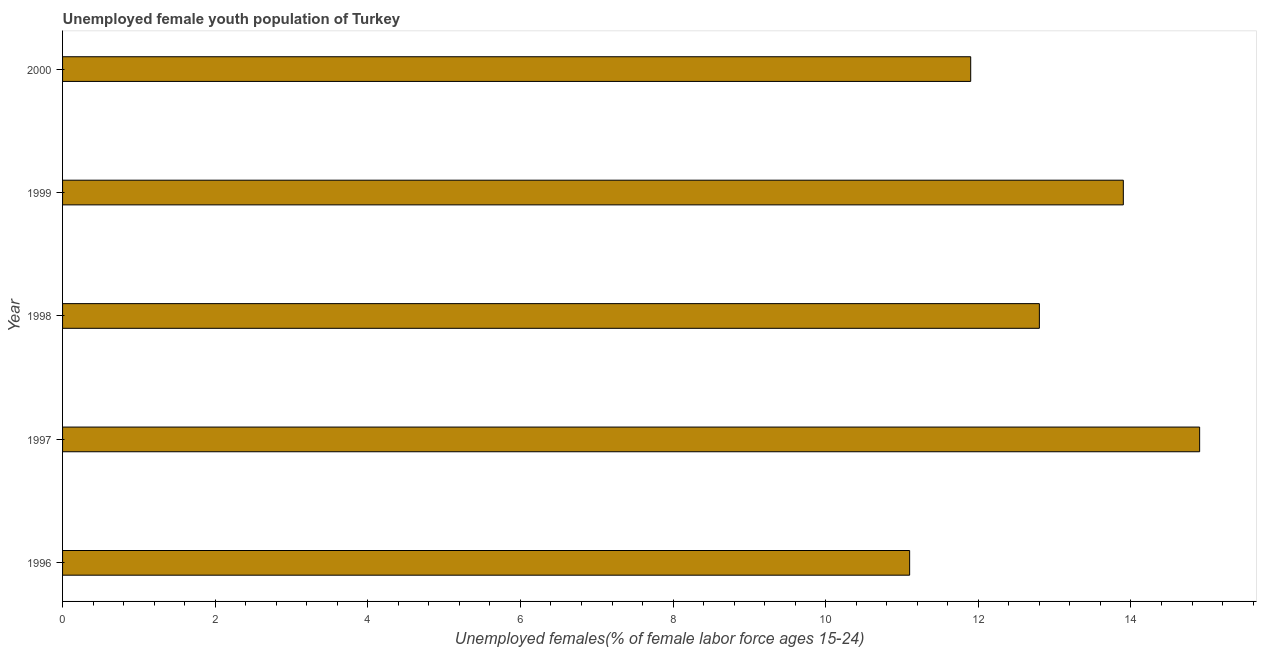What is the title of the graph?
Provide a succinct answer. Unemployed female youth population of Turkey. What is the label or title of the X-axis?
Keep it short and to the point. Unemployed females(% of female labor force ages 15-24). What is the label or title of the Y-axis?
Offer a terse response. Year. What is the unemployed female youth in 1999?
Provide a short and direct response. 13.9. Across all years, what is the maximum unemployed female youth?
Give a very brief answer. 14.9. Across all years, what is the minimum unemployed female youth?
Offer a very short reply. 11.1. In which year was the unemployed female youth minimum?
Your answer should be very brief. 1996. What is the sum of the unemployed female youth?
Make the answer very short. 64.6. What is the average unemployed female youth per year?
Ensure brevity in your answer.  12.92. What is the median unemployed female youth?
Ensure brevity in your answer.  12.8. In how many years, is the unemployed female youth greater than 5.2 %?
Provide a succinct answer. 5. What is the ratio of the unemployed female youth in 1998 to that in 2000?
Your response must be concise. 1.08. Is the difference between the unemployed female youth in 1997 and 2000 greater than the difference between any two years?
Give a very brief answer. No. Is the sum of the unemployed female youth in 1999 and 2000 greater than the maximum unemployed female youth across all years?
Offer a terse response. Yes. In how many years, is the unemployed female youth greater than the average unemployed female youth taken over all years?
Your response must be concise. 2. How many bars are there?
Provide a short and direct response. 5. How many years are there in the graph?
Give a very brief answer. 5. Are the values on the major ticks of X-axis written in scientific E-notation?
Offer a very short reply. No. What is the Unemployed females(% of female labor force ages 15-24) of 1996?
Make the answer very short. 11.1. What is the Unemployed females(% of female labor force ages 15-24) in 1997?
Ensure brevity in your answer.  14.9. What is the Unemployed females(% of female labor force ages 15-24) of 1998?
Offer a terse response. 12.8. What is the Unemployed females(% of female labor force ages 15-24) in 1999?
Your answer should be compact. 13.9. What is the Unemployed females(% of female labor force ages 15-24) in 2000?
Offer a very short reply. 11.9. What is the difference between the Unemployed females(% of female labor force ages 15-24) in 1996 and 2000?
Your answer should be very brief. -0.8. What is the difference between the Unemployed females(% of female labor force ages 15-24) in 1997 and 1999?
Offer a very short reply. 1. What is the difference between the Unemployed females(% of female labor force ages 15-24) in 1997 and 2000?
Give a very brief answer. 3. What is the difference between the Unemployed females(% of female labor force ages 15-24) in 1999 and 2000?
Offer a very short reply. 2. What is the ratio of the Unemployed females(% of female labor force ages 15-24) in 1996 to that in 1997?
Your response must be concise. 0.74. What is the ratio of the Unemployed females(% of female labor force ages 15-24) in 1996 to that in 1998?
Provide a succinct answer. 0.87. What is the ratio of the Unemployed females(% of female labor force ages 15-24) in 1996 to that in 1999?
Keep it short and to the point. 0.8. What is the ratio of the Unemployed females(% of female labor force ages 15-24) in 1996 to that in 2000?
Make the answer very short. 0.93. What is the ratio of the Unemployed females(% of female labor force ages 15-24) in 1997 to that in 1998?
Give a very brief answer. 1.16. What is the ratio of the Unemployed females(% of female labor force ages 15-24) in 1997 to that in 1999?
Ensure brevity in your answer.  1.07. What is the ratio of the Unemployed females(% of female labor force ages 15-24) in 1997 to that in 2000?
Your answer should be very brief. 1.25. What is the ratio of the Unemployed females(% of female labor force ages 15-24) in 1998 to that in 1999?
Keep it short and to the point. 0.92. What is the ratio of the Unemployed females(% of female labor force ages 15-24) in 1998 to that in 2000?
Offer a very short reply. 1.08. What is the ratio of the Unemployed females(% of female labor force ages 15-24) in 1999 to that in 2000?
Your answer should be compact. 1.17. 